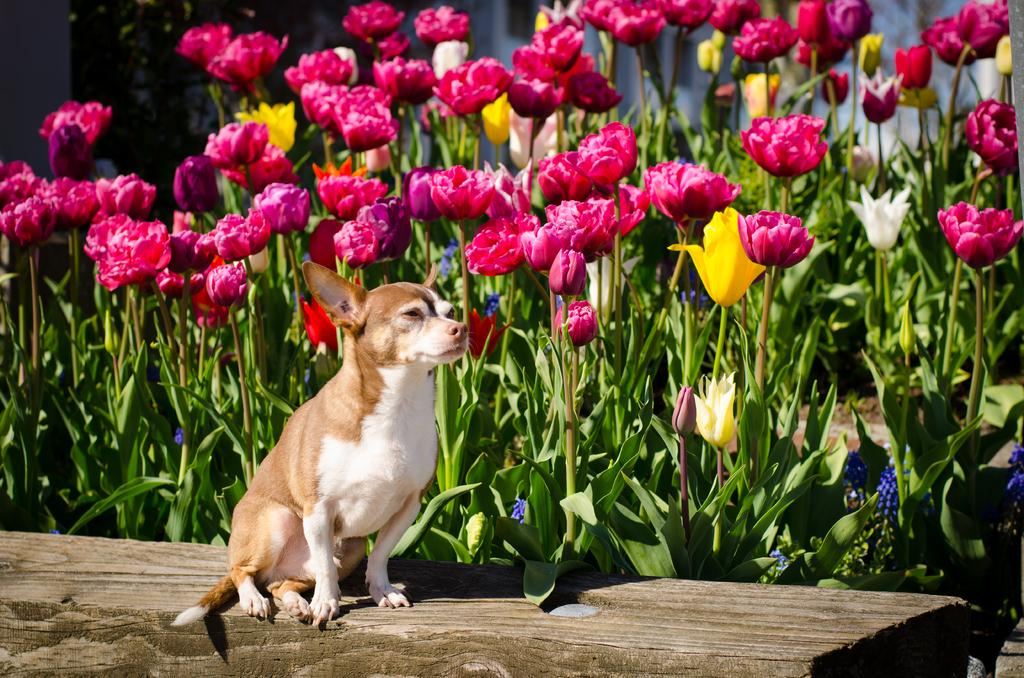What type of animal is in the image? There is a dog in the image. Where is the dog located? The dog is on a bench. What type of flowers are in the image? There are rose flowers in the image. What other plants are in the image besides the roses? There are plants in the image. What type of behavior does the hose exhibit in the image? There is no hose present in the image, so it cannot exhibit any behavior. 